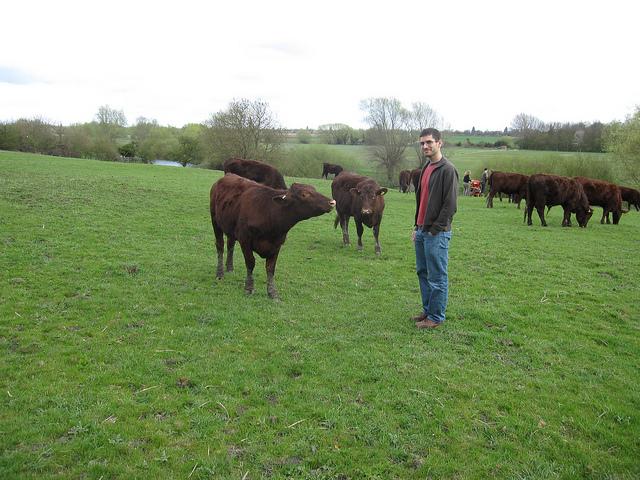Are the cows facing the same direction?
Quick response, please. No. Are all the people in this picture wearing hats?
Give a very brief answer. No. What colors make up the cow's coat?
Keep it brief. Brown. What do these cows produce?
Concise answer only. Milk. How many white feet?
Concise answer only. 0. Is this person looking at the camera?
Concise answer only. Yes. Where is the man?
Keep it brief. In field. What animal is this person near?
Quick response, please. Cow. 